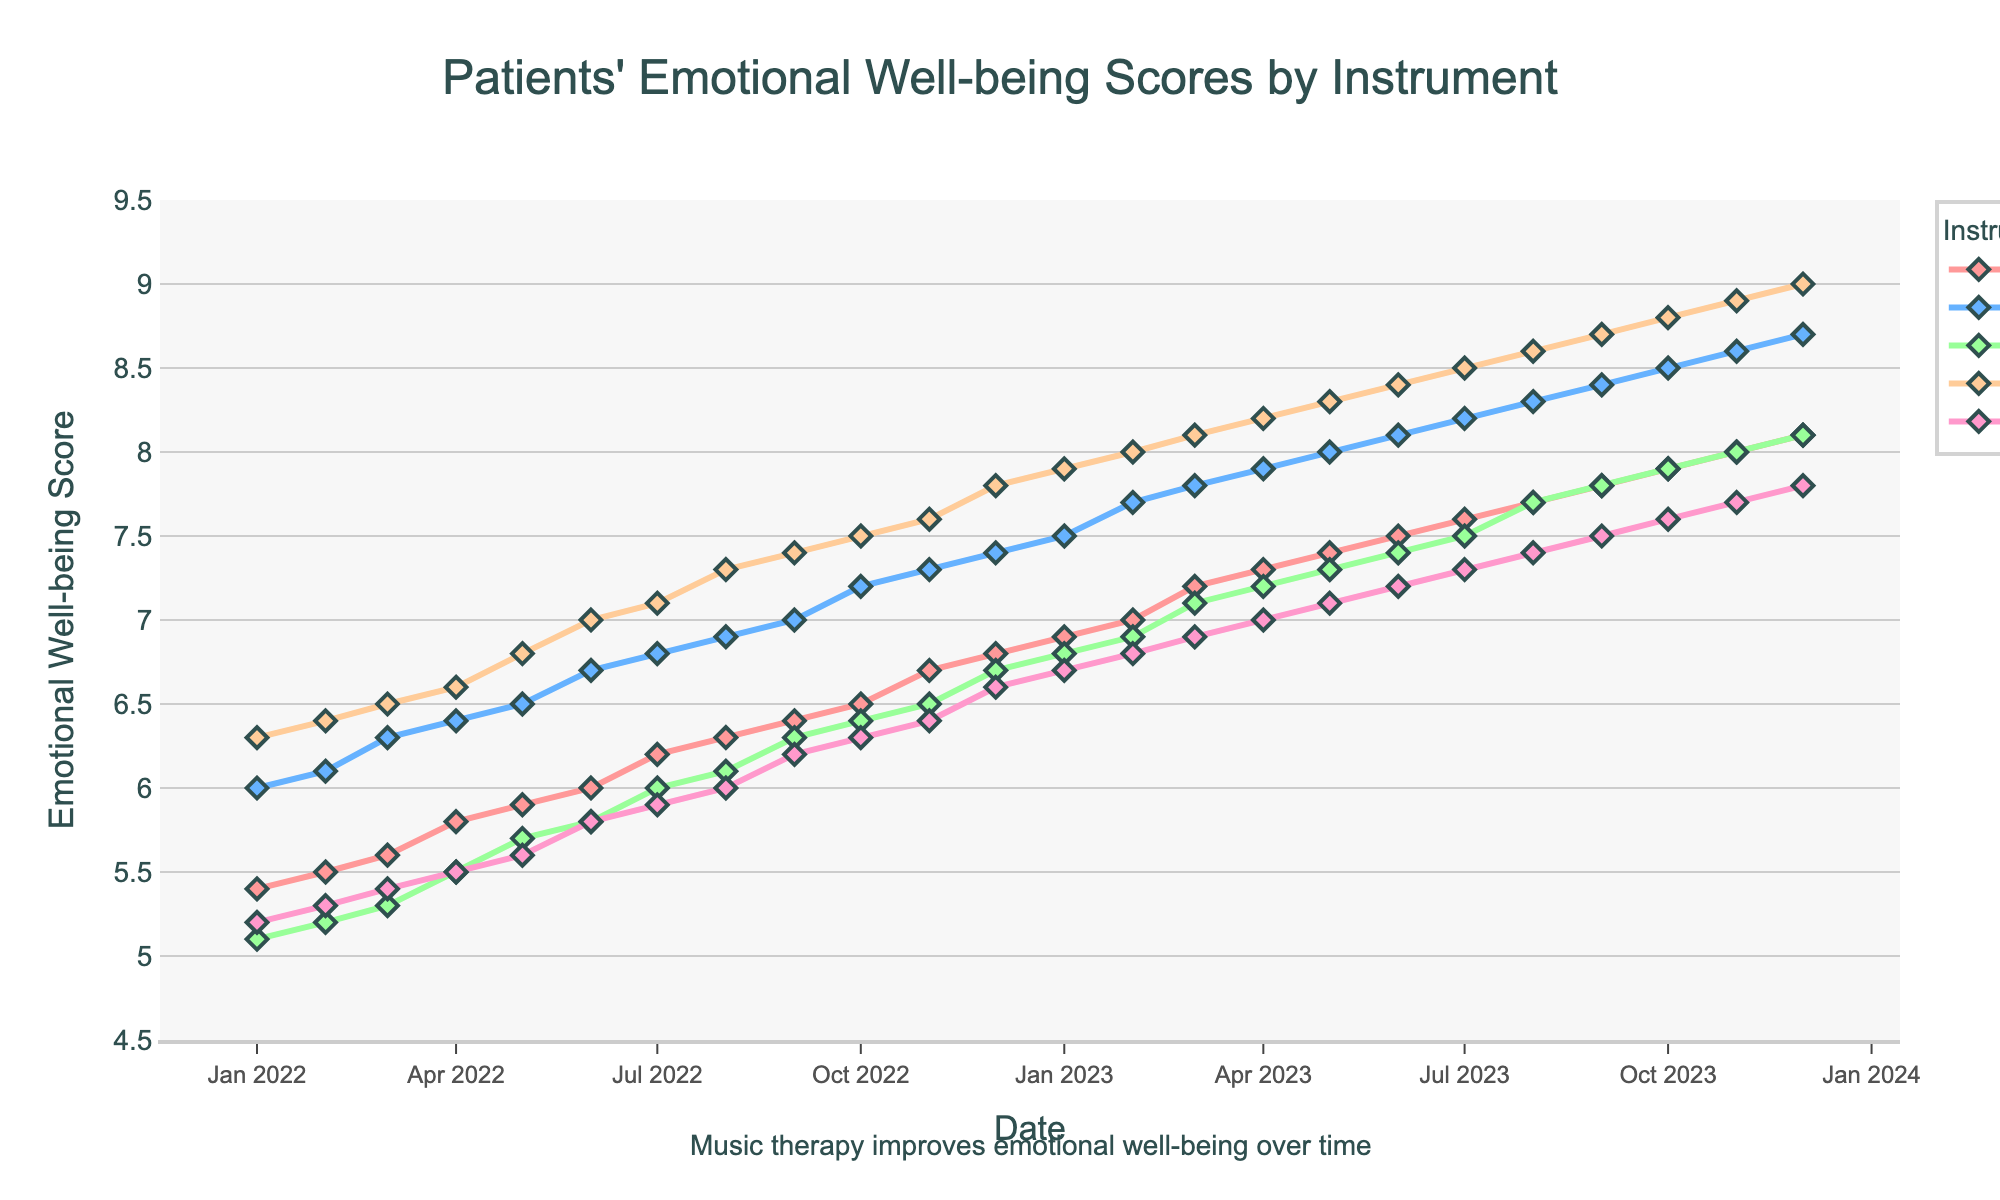What is the title of the plot? The title of the plot is typically found at the top and provides the main context or topic of the data visualized. Read the title directly from the plot.
Answer: Patients' Emotional Well-being Scores by Instrument How many instruments are tracked in the plot? Count the number of distinct instruments as indicated by the lines and legend in the plot.
Answer: 5 Which instrument has the highest score at the end of the period in December 2023? Look at the y-values for each instrument in December 2023, and identify the instrument with the highest value.
Answer: Drums What is the trend of the emotional well-being score for piano from January 2022 to December 2023? Observe the pattern of the line representing piano scores over time; note the general direction or changes in the line (increasing, decreasing, steady).
Answer: Increasing By how many points did the violin's score increase from January 2022 to December 2023? Subtract the violin's score in January 2022 from its score in December 2023. Calculate 8.1 (December 2023) - 5.1 (January 2022).
Answer: 3.0 Which month and year did the flute score exceed 7.0 for the first time? Track the flute's score line and find the first instance where it crosses the 7.0 mark, then read the corresponding month and year.
Answer: April 2023 In which month of 2022 did the guitar score show the highest increase compared to the previous month? Calculate the differences month-to-month for the guitar score in 2022 and identify the highest jump. E.g., from June to July 2022.
Answer: March 2022 Compare the emotional well-being scores for drums and flute in December 2022. Which instrument had a higher score? Directly compare the y-values of drums and flute for December 2022.
Answer: Drums What is the average emotional well-being score for the guitar over the entire period? Sum the guitar scores for all months and divide by the total number of months (24). Steps: 6.0+6.1+...+8.7 = 172.4, then 172.4/24.
Answer: 7.18 Which instrument showed the least variability in emotional well-being scores over the two years? Identify variability by observing how stable the scores are over time or calculate the range/standard deviation.
Answer: Flute 